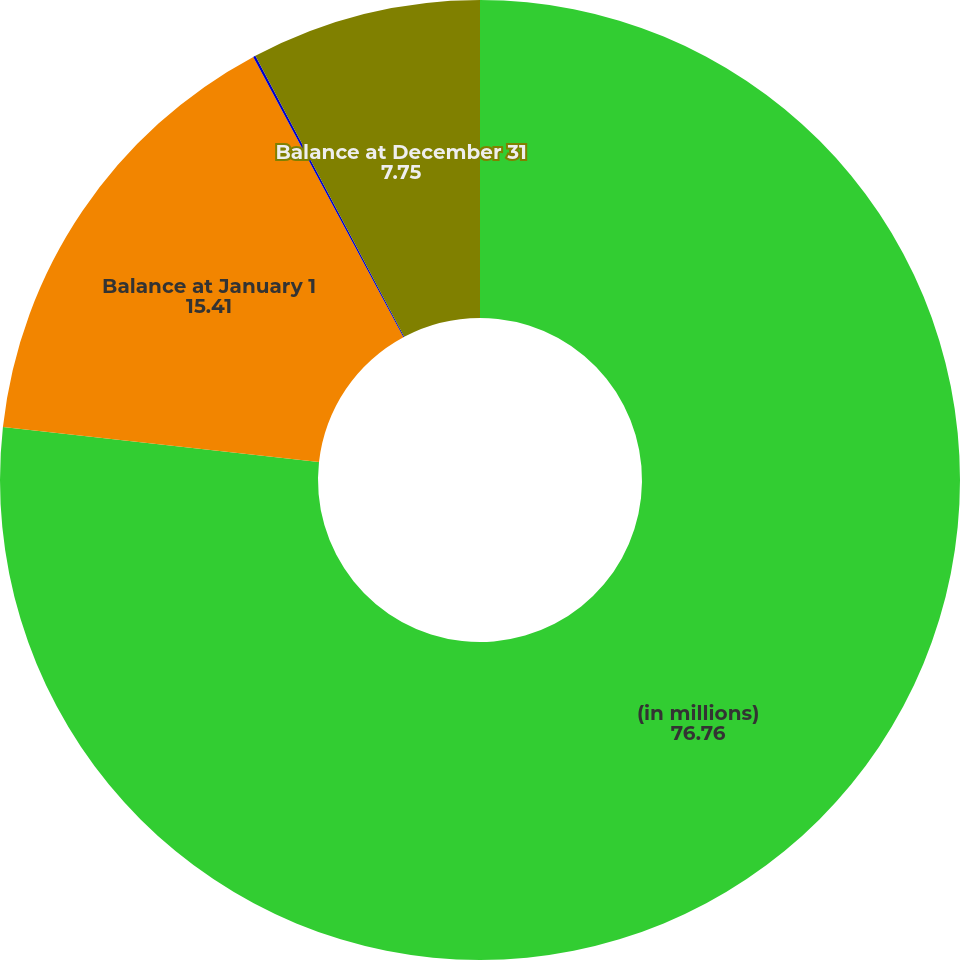<chart> <loc_0><loc_0><loc_500><loc_500><pie_chart><fcel>(in millions)<fcel>Balance at January 1<fcel>Sales<fcel>Balance at December 31<nl><fcel>76.76%<fcel>15.41%<fcel>0.08%<fcel>7.75%<nl></chart> 